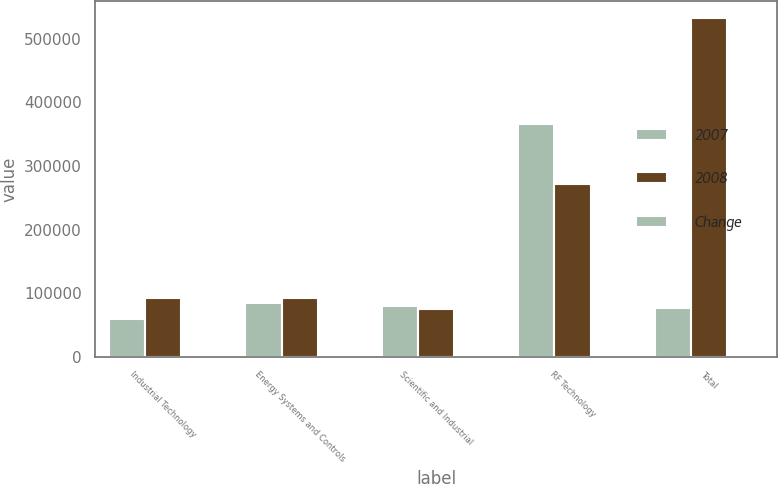Convert chart. <chart><loc_0><loc_0><loc_500><loc_500><stacked_bar_chart><ecel><fcel>Industrial Technology<fcel>Energy Systems and Controls<fcel>Scientific and Industrial<fcel>RF Technology<fcel>Total<nl><fcel>2007<fcel>59128<fcel>84997<fcel>80020<fcel>365669<fcel>77427<nl><fcel>2008<fcel>93076<fcel>93102<fcel>74834<fcel>271305<fcel>532317<nl><fcel>Change<fcel>36.5<fcel>8.7<fcel>6.9<fcel>34.8<fcel>10.8<nl></chart> 